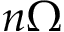<formula> <loc_0><loc_0><loc_500><loc_500>n \Omega</formula> 